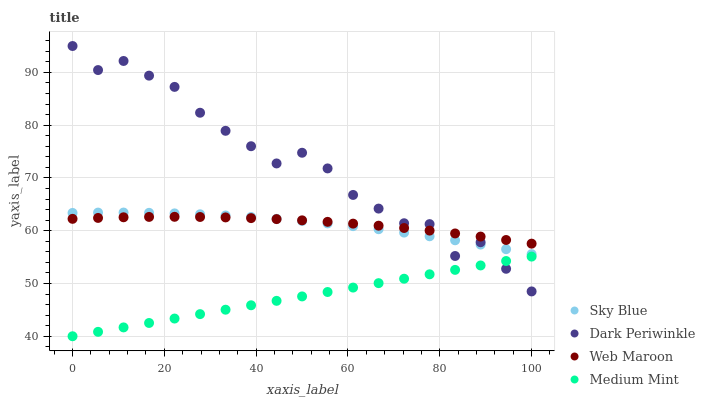Does Medium Mint have the minimum area under the curve?
Answer yes or no. Yes. Does Dark Periwinkle have the maximum area under the curve?
Answer yes or no. Yes. Does Sky Blue have the minimum area under the curve?
Answer yes or no. No. Does Sky Blue have the maximum area under the curve?
Answer yes or no. No. Is Medium Mint the smoothest?
Answer yes or no. Yes. Is Dark Periwinkle the roughest?
Answer yes or no. Yes. Is Sky Blue the smoothest?
Answer yes or no. No. Is Sky Blue the roughest?
Answer yes or no. No. Does Medium Mint have the lowest value?
Answer yes or no. Yes. Does Sky Blue have the lowest value?
Answer yes or no. No. Does Dark Periwinkle have the highest value?
Answer yes or no. Yes. Does Sky Blue have the highest value?
Answer yes or no. No. Is Medium Mint less than Web Maroon?
Answer yes or no. Yes. Is Web Maroon greater than Medium Mint?
Answer yes or no. Yes. Does Dark Periwinkle intersect Sky Blue?
Answer yes or no. Yes. Is Dark Periwinkle less than Sky Blue?
Answer yes or no. No. Is Dark Periwinkle greater than Sky Blue?
Answer yes or no. No. Does Medium Mint intersect Web Maroon?
Answer yes or no. No. 